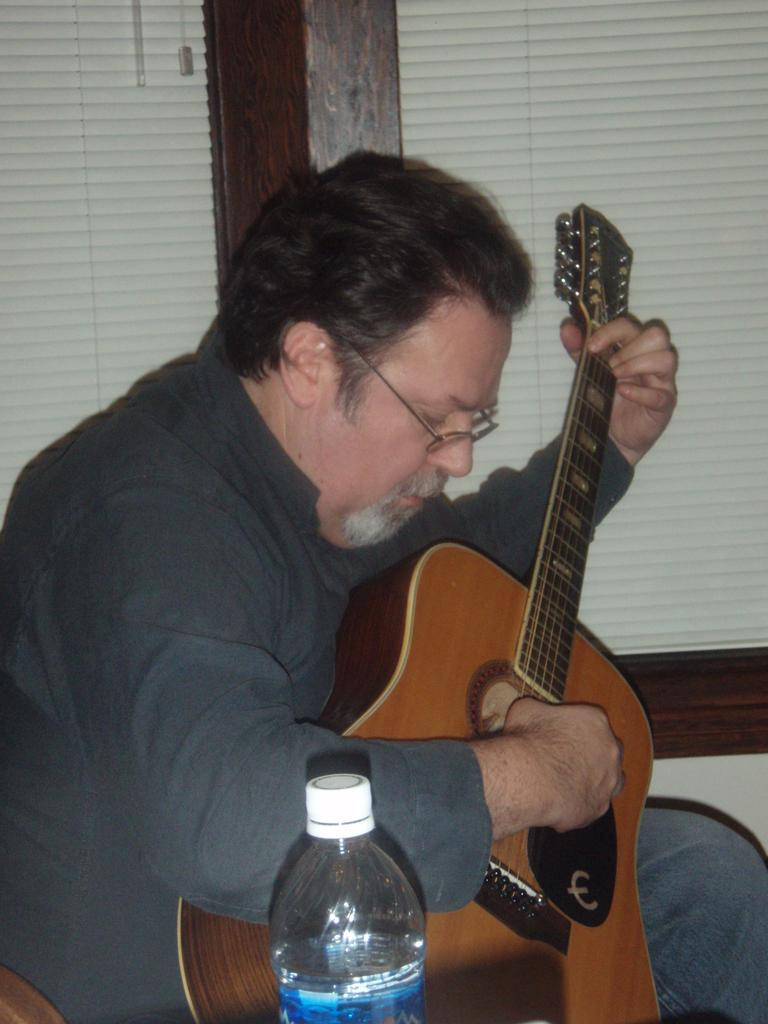What is the man in the image doing? The man is sitting and playing the guitar. Can you describe the man's position in the image? The man is sitting. What object is present in the image besides the man and his guitar? There is a bottle in the image. What type of clouds can be seen in the image? There are no clouds visible in the image, as it features a man sitting and playing the guitar, along with a bottle. 